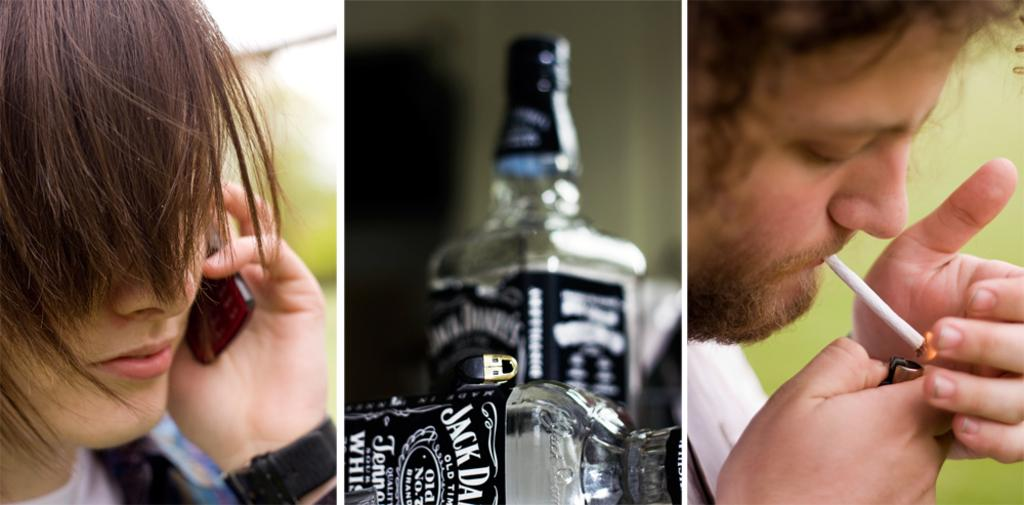<image>
Render a clear and concise summary of the photo. a beer bottle with the words Jack Daniels on it 